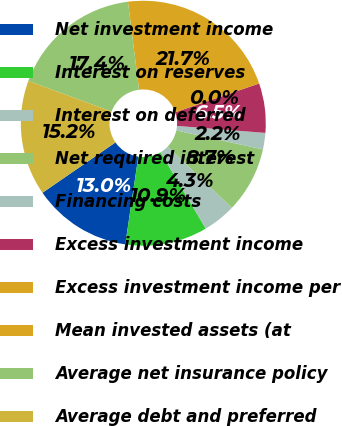<chart> <loc_0><loc_0><loc_500><loc_500><pie_chart><fcel>Net investment income<fcel>Interest on reserves<fcel>Interest on deferred<fcel>Net required interest<fcel>Financing costs<fcel>Excess investment income<fcel>Excess investment income per<fcel>Mean invested assets (at<fcel>Average net insurance policy<fcel>Average debt and preferred<nl><fcel>13.04%<fcel>10.87%<fcel>4.35%<fcel>8.7%<fcel>2.17%<fcel>6.52%<fcel>0.0%<fcel>21.74%<fcel>17.39%<fcel>15.22%<nl></chart> 